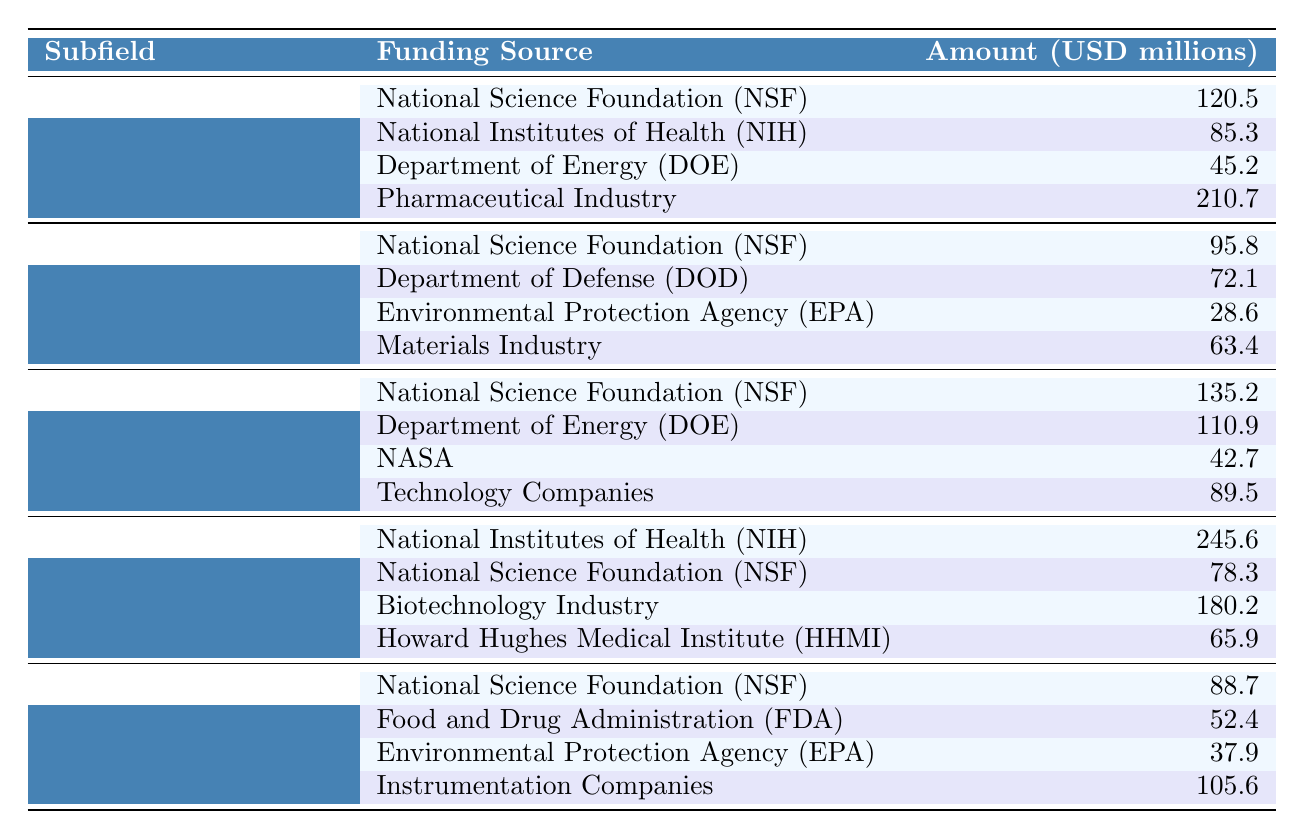What's the total funding amount for Organic Chemistry? To find the total funding for Organic Chemistry, I sum up the amounts from all funding sources: 120.5 + 85.3 + 45.2 + 210.7 = 461.7 million USD.
Answer: 461.7 million USD Which funding source contributed the highest amount to Biochemistry? Looking at the Biochemistry row, the National Institutes of Health (NIH) contributed the highest amount, which is 245.6 million USD.
Answer: National Institutes of Health (NIH) What is the sum of funding amount from NSF across all subfields? I will find the amounts from each subfield for NSF: Organic Chemistry: 120.5 million, Inorganic Chemistry: 95.8 million, Physical Chemistry: 135.2 million, Biochemistry: 78.3 million, Analytical Chemistry: 88.7 million. Summing these gives: 120.5 + 95.8 + 135.2 + 78.3 + 88.7 = 518.5 million USD.
Answer: 518.5 million USD Is the funding amount from the Pharmaceutical Industry greater than that from the NIH in Biochemistry? I compare the amounts between these two sources for Biochemistry: Pharmaceutical Industry: 180.2 million USD and NIH: 245.6 million USD. Since 180.2 is less than 245.6, the statement is false.
Answer: No Which subfield received the least amount of funding overall? To determine the subfield with the least total funding, I calculate the total for each subfield: Organic Chemistry: 461.7 million, Inorganic Chemistry: 259.9 million, Physical Chemistry: 378.3 million, Biochemistry: 570 million, Analytical Chemistry: 284.6 million. Among these, Inorganic Chemistry has the least amount at 259.9 million USD.
Answer: Inorganic Chemistry How much more funding is allocated to Physical Chemistry than to Analytical Chemistry? First, I find the total amounts for Physical Chemistry (378.3 million USD) and Analytical Chemistry (284.6 million USD). The difference would be 378.3 - 284.6 = 93.7 million USD.
Answer: 93.7 million USD True or False: The Department of Energy (DOE) is a funding source for both Organic Chemistry and Physical Chemistry. Checking the table, I find DOE listed as a funding source for Organic Chemistry (45.2 million USD) and for Physical Chemistry (110.9 million USD), so the statement is true.
Answer: True What is the average funding amount provided by the Department of Energy (DOE) across the subfields it supports? The funding amounts from DOE are: Organic Chemistry: 45.2 million, Inorganic Chemistry: N/A, Physical Chemistry: 110.9 million. The only applicable values are 45.2 million and 110.9 million, giving an average of (45.2 + 110.9) / 2 = 78.05 million USD.
Answer: 78.05 million USD Which subfield has the largest total funding amount, and how much is it? The totals for each subfield are as follows: Organic Chemistry: 461.7 million, Inorganic Chemistry: 259.9 million, Physical Chemistry: 378.3 million, Biochemistry: 570 million, Analytical Chemistry: 284.6 million. The largest total funding amount is for Biochemistry, which is 570 million USD.
Answer: Biochemistry; 570 million USD 